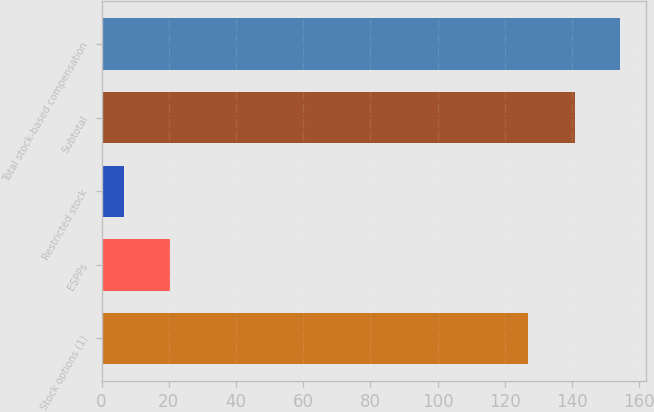Convert chart to OTSL. <chart><loc_0><loc_0><loc_500><loc_500><bar_chart><fcel>Stock options (1)<fcel>ESPPs<fcel>Restricted stock<fcel>Subtotal<fcel>Total stock-based compensation<nl><fcel>127<fcel>20.22<fcel>6.8<fcel>141<fcel>154.42<nl></chart> 